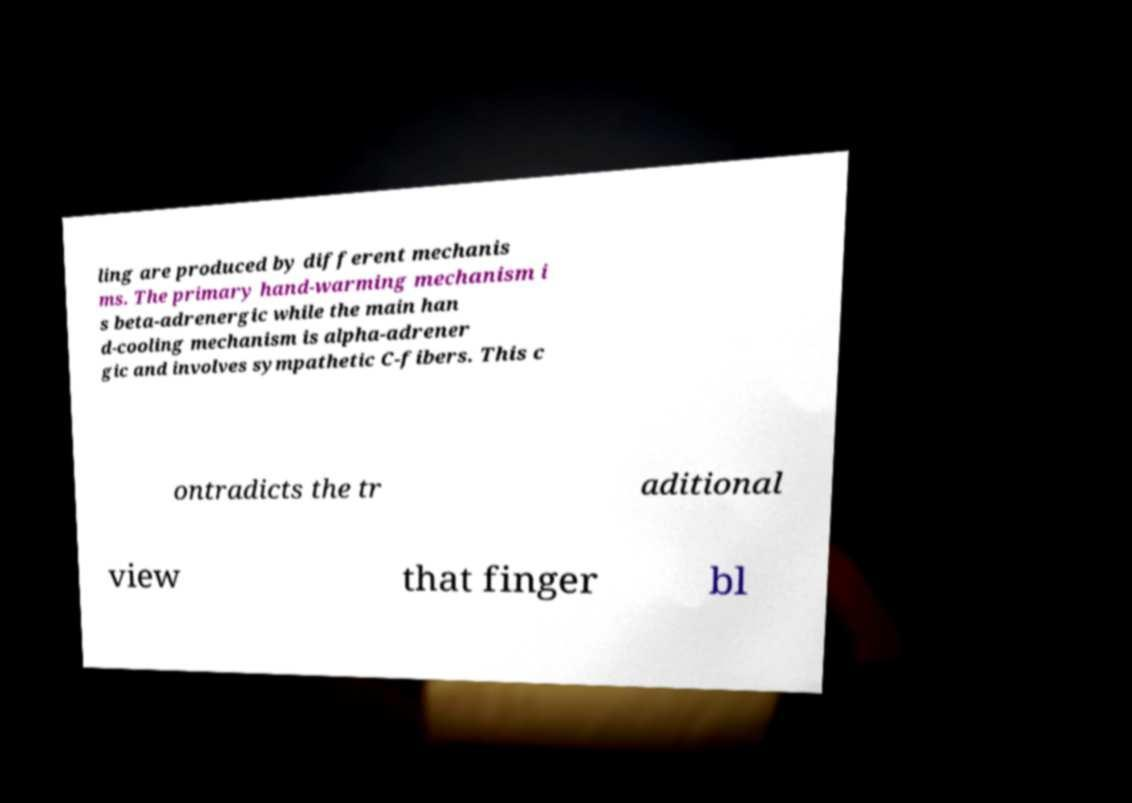Please read and relay the text visible in this image. What does it say? ling are produced by different mechanis ms. The primary hand-warming mechanism i s beta-adrenergic while the main han d-cooling mechanism is alpha-adrener gic and involves sympathetic C-fibers. This c ontradicts the tr aditional view that finger bl 